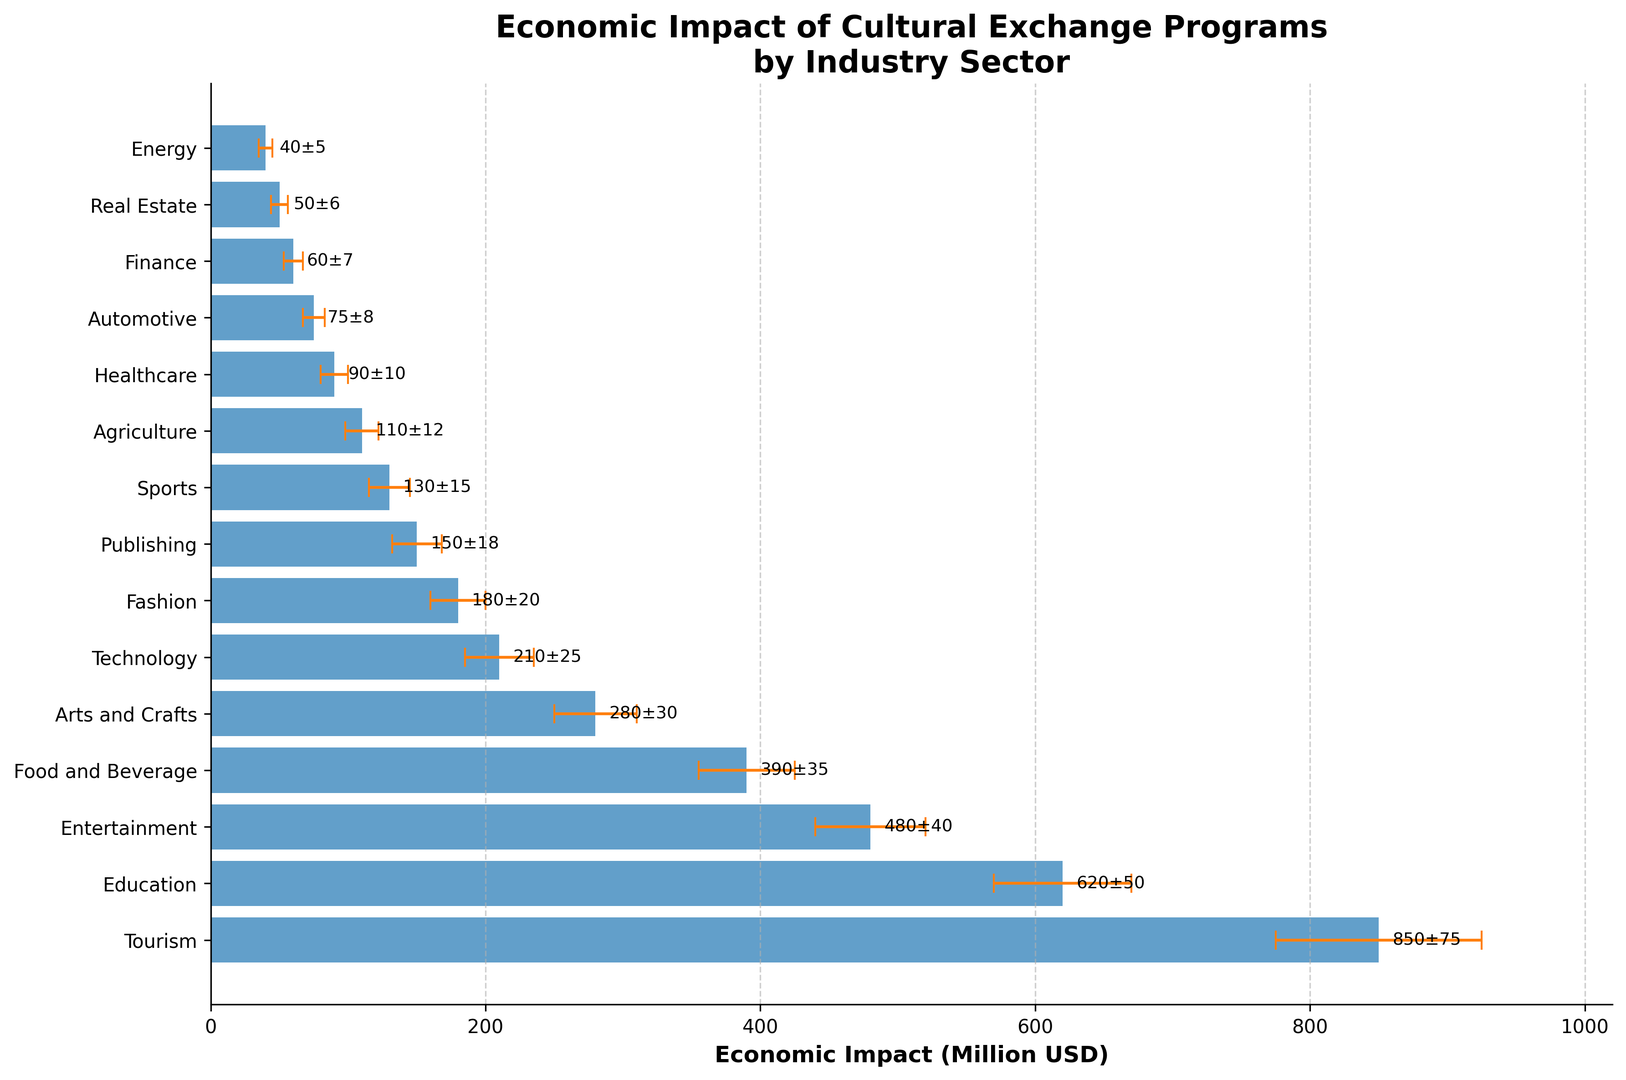What is the industry sector with the highest average economic impact? By examining the bar lengths, we see that the "Tourism" sector has the longest bar, indicating the highest economic impact.
Answer: Tourism How much more is the average economic impact of the "Tourism" sector compared to the "Education" sector? The "Tourism" sector has an average economic impact of 850 million USD, while the "Education" sector has 620 million USD. The difference is 850 - 620 = 230 million USD.
Answer: 230 million USD What is the combined economic impact of the "Technology" and "Fashion" sectors? The "Technology" sector has an impact of 210 million USD, and the "Fashion" sector has 180 million USD. Combined, they total 210 + 180 = 390 million USD.
Answer: 390 million USD Which sectors have an average economic impact above 400 million USD? The sectors with average economic impacts above 400 million USD are "Tourism" (850 million USD), "Education" (620 million USD), and "Entertainment" (480 million USD).
Answer: Tourism, Education, Entertainment What is the average economic impact value for the sectors in the lower half of the list? The lower half includes sectors from "Publishing" (150 million USD) to "Energy" (40 million USD). Their sum is 150 + 130 + 110 + 90 + 75 + 60 + 50 + 40 = 705 million USD. There are 8 sectors, so the average is \( \frac{705}{8} \approx 88.125 \) million USD.
Answer: 88.125 million USD Which sector has the smallest error margin? By examining the error bars, we find that the "Energy" sector has the smallest error margin of 5 million USD.
Answer: Energy Is the economic impact of the "Arts and Crafts" sector greater than the total economic impact of the "Finance" and "Real Estate" sectors combined? The "Arts and Crafts" sector has an impact of 280 million USD. The combined impact of "Finance" (60 million USD) and "Real Estate" (50 million USD) is 60 + 50 = 110 million USD. 280 is greater than 110.
Answer: Yes What percentage of the total economic impact does the "Agriculture" sector contribute? First, sum the average impacts: 850 + 620 + 480 + 390 + 280 + 210 + 180 + 150 + 130 + 110 + 90 + 75 + 60 + 50 + 40 = 3715 million USD. The "Agriculture" sector's impact is 110 million USD. The percentage is \( \frac{110}{3715} \times 100 \approx 2.96\% \).
Answer: 2.96% What is the difference in error margins between the "Healthcare" and "Energy" sectors? The "Healthcare" sector has an error margin of 10 million USD, and the "Energy" sector has an error margin of 5 million USD. The difference is 10 - 5 = 5 million USD.
Answer: 5 million USD Which sectors have error margins greater than 30 million USD? The sectors with error margins greater than 30 million USD are "Tourism" (75 million USD), "Education" (50 million USD), "Entertainment" (40 million USD), "Food and Beverage" (35 million USD), and "Arts and Crafts" (30 million USD).
Answer: Tourism, Education, Entertainment, Food and Beverage 